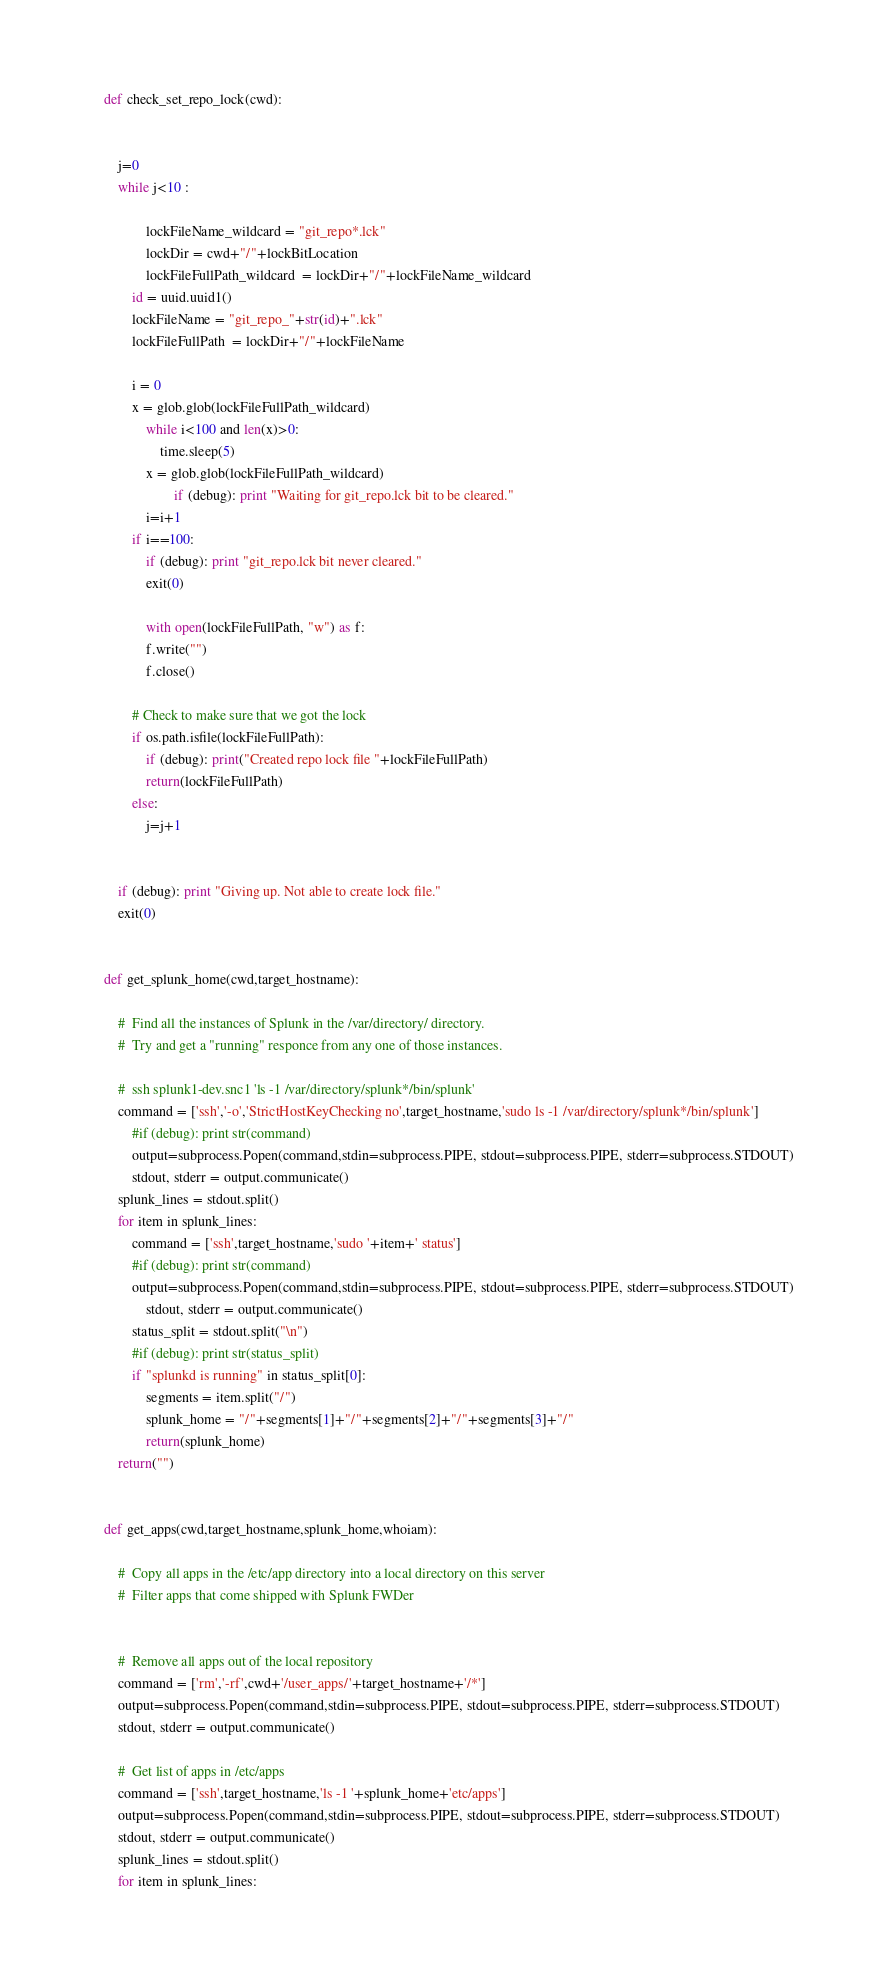<code> <loc_0><loc_0><loc_500><loc_500><_Python_>def check_set_repo_lock(cwd):


	j=0
	while j<10 :

       		lockFileName_wildcard = "git_repo*.lck"
       		lockDir = cwd+"/"+lockBitLocation
       		lockFileFullPath_wildcard  = lockDir+"/"+lockFileName_wildcard
		id = uuid.uuid1()
		lockFileName = "git_repo_"+str(id)+".lck"
		lockFileFullPath  = lockDir+"/"+lockFileName 

		i = 0
		x = glob.glob(lockFileFullPath_wildcard)
       		while i<100 and len(x)>0:
       			time.sleep(5)
			x = glob.glob(lockFileFullPath_wildcard) 
               		if (debug): print "Waiting for git_repo.lck bit to be cleared."
			i=i+1
		if i==100:
			if (debug): print "git_repo.lck bit never cleared."
			exit(0)

       		with open(lockFileFullPath, "w") as f:
			f.write("")
			f.close()

		# Check to make sure that we got the lock
		if os.path.isfile(lockFileFullPath):
			if (debug): print("Created repo lock file "+lockFileFullPath)
			return(lockFileFullPath)
		else:
			j=j+1


	if (debug): print "Giving up. Not able to create lock file."
	exit(0)


def get_splunk_home(cwd,target_hostname):

	#  Find all the instances of Splunk in the /var/directory/ directory.
	#  Try and get a "running" responce from any one of those instances.

	#  ssh splunk1-dev.snc1 'ls -1 /var/directory/splunk*/bin/splunk'
	command = ['ssh','-o','StrictHostKeyChecking no',target_hostname,'sudo ls -1 /var/directory/splunk*/bin/splunk']
        #if (debug): print str(command)
        output=subprocess.Popen(command,stdin=subprocess.PIPE, stdout=subprocess.PIPE, stderr=subprocess.STDOUT)
        stdout, stderr = output.communicate()	
	splunk_lines = stdout.split()
	for item in splunk_lines:
		command = ['ssh',target_hostname,'sudo '+item+' status']
		#if (debug): print str(command)
		output=subprocess.Popen(command,stdin=subprocess.PIPE, stdout=subprocess.PIPE, stderr=subprocess.STDOUT)
        	stdout, stderr = output.communicate()
		status_split = stdout.split("\n")
		#if (debug): print str(status_split)
		if "splunkd is running" in status_split[0]:
			segments = item.split("/")
			splunk_home = "/"+segments[1]+"/"+segments[2]+"/"+segments[3]+"/"
			return(splunk_home)
	return("")


def get_apps(cwd,target_hostname,splunk_home,whoiam):

	#  Copy all apps in the /etc/app directory into a local directory on this server
	#  Filter apps that come shipped with Splunk FWDer


	#  Remove all apps out of the local repository
	command = ['rm','-rf',cwd+'/user_apps/'+target_hostname+'/*']
	output=subprocess.Popen(command,stdin=subprocess.PIPE, stdout=subprocess.PIPE, stderr=subprocess.STDOUT)
	stdout, stderr = output.communicate()

	#  Get list of apps in /etc/apps
	command = ['ssh',target_hostname,'ls -1 '+splunk_home+'etc/apps']
	output=subprocess.Popen(command,stdin=subprocess.PIPE, stdout=subprocess.PIPE, stderr=subprocess.STDOUT)
	stdout, stderr = output.communicate()
	splunk_lines = stdout.split()
	for item in splunk_lines:</code> 